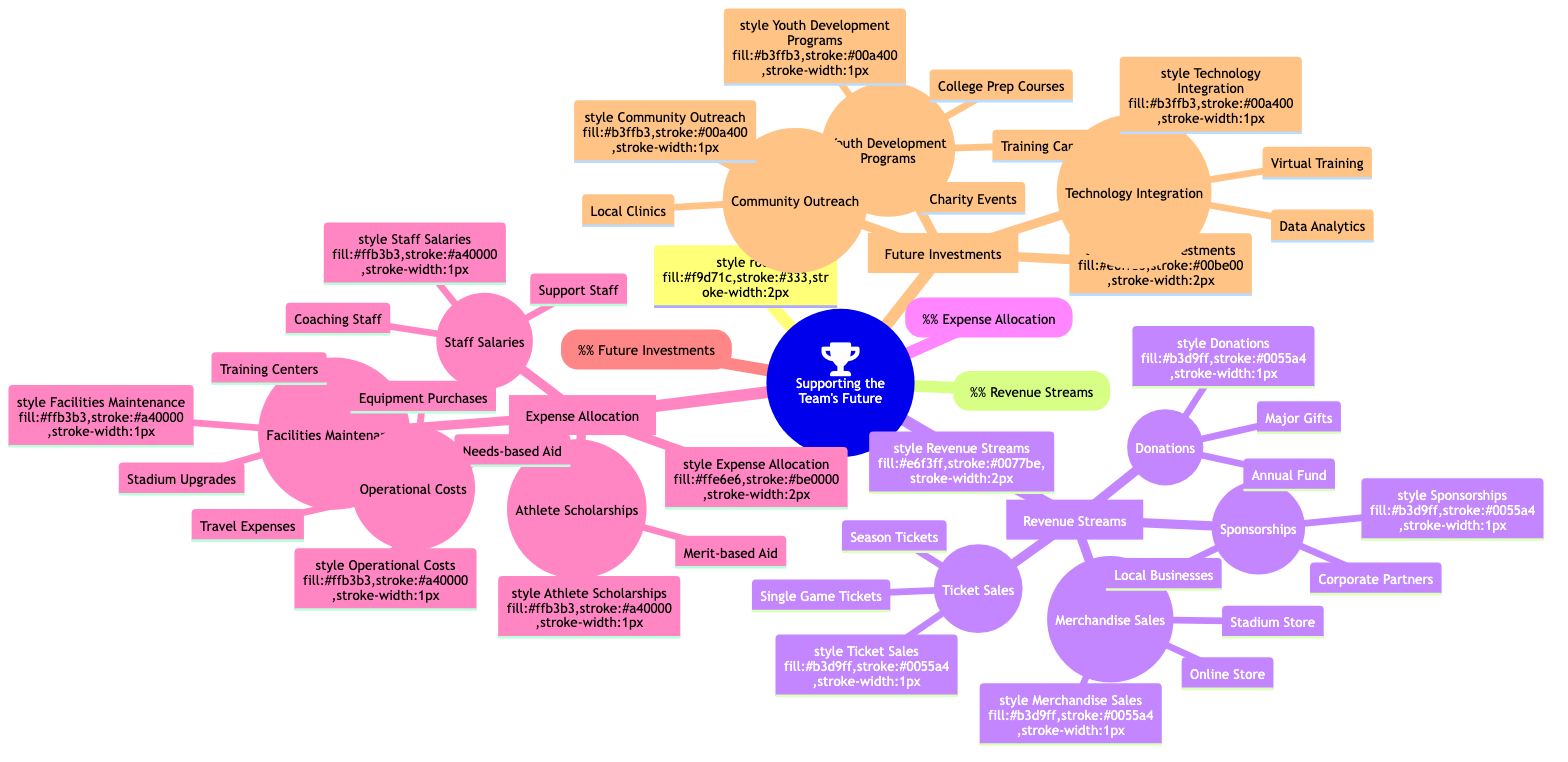What's included under Revenue Streams? The diagram lists four categories under Revenue Streams: Ticket Sales, Merchandise Sales, Sponsorships, and Donations.
Answer: Ticket Sales, Merchandise Sales, Sponsorships, Donations What are the two types of Ticket Sales? The diagram specifies that Ticket Sales are divided into two categories: Season Tickets and Single Game Tickets.
Answer: Season Tickets, Single Game Tickets How many categories are there under Expense Allocation? There are four main categories listed under Expense Allocation: Athlete Scholarships, Facilities Maintenance, Staff Salaries, and Operational Costs. Counting these gives a total of four categories.
Answer: 4 Which category has the most subcategories listed in the diagram? By examining the diagram, it's clear that Expense Allocation has four categories, but when considering the subcategories, the category with the most is also Expense Allocation, which has four subcategories categorized further into two in each.
Answer: Expense Allocation Which future investment focuses on youth programs? The mind map indicates that the category Youth Development Programs is focused specifically on programs for youth, such as Training Camps and College Prep Courses.
Answer: Youth Development Programs What does the Corporate Partners subcategory relate to? The diagram shows that Corporate Partners falls under Sponsorships, indicating that it focuses on forming long-term agreements with corporate entities.
Answer: Long-term Agreements Which area of funding focuses on enhancing team performance? The Technology Integration category under Future Investments covers enhancements in team performance through Data Analytics and Virtual Training.
Answer: Technology Integration What could be the impact of Major Gifts in Donations? Major Gifts in Donations relate to Naming Rights for Facilities, suggesting a significant financial impact on the team by providing naming rights for facilities to major donors.
Answer: Naming Rights for Facilities How do the Needs-based Aid and Merit-based Aid subcategories differ? Needs-based Aid focuses on providing financial support programs for athletes in need, while Merit-based Aid aims at recruiting top talent based on their abilities, indicating different criteria and goals for assistance.
Answer: Financial Support Programs, Recruiting Top Talent 